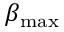<formula> <loc_0><loc_0><loc_500><loc_500>\beta _ { \max }</formula> 